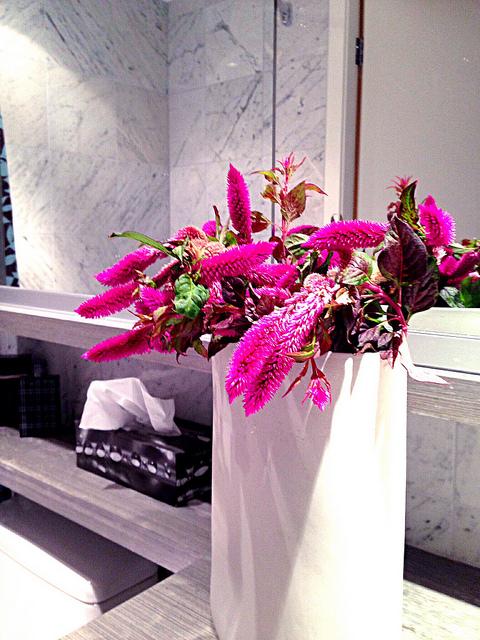What color are the flowers?
Quick response, please. Pink. Were these flowers given for a special occasion?
Short answer required. Yes. How many flower vases?
Answer briefly. 1. 